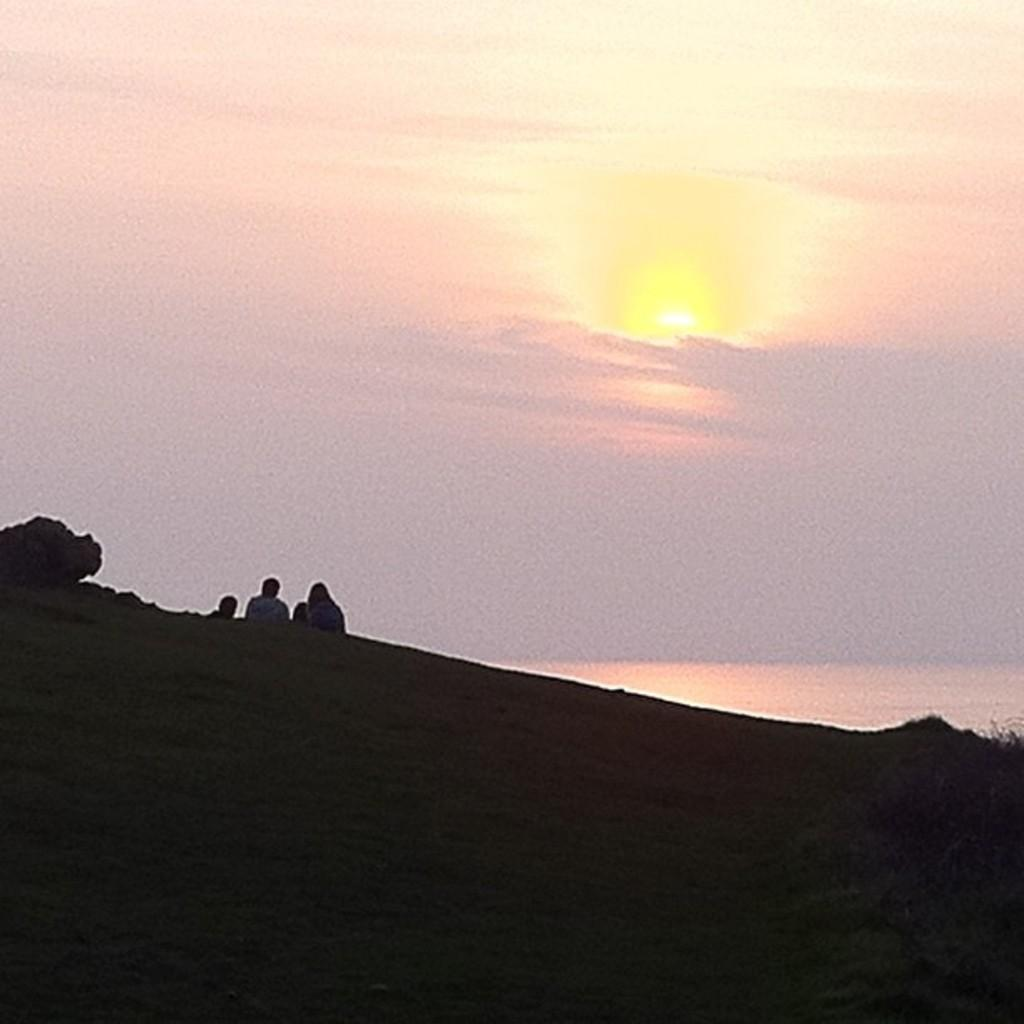What type of surface can be seen in the image? There is ground visible in the image. Who or what is present in the image? There are people in the image. What is visible in the background of the image? The sky is visible in the image. What can be seen in the sky? Clouds and the sun are present in the sky. What type of blade is being used by the people in the image? There is no blade visible in the image; the people are not using any tools or objects. 